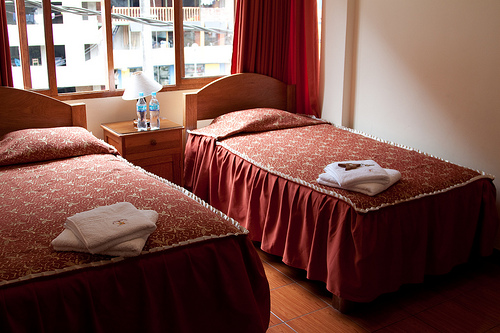Please provide a short description for this region: [0.08, 0.56, 0.34, 0.68]. The region shows two fluffy white towels neatly placed at the foot of a bed with a vibrant red bedspread, suggesting a well-maintained guest room. 